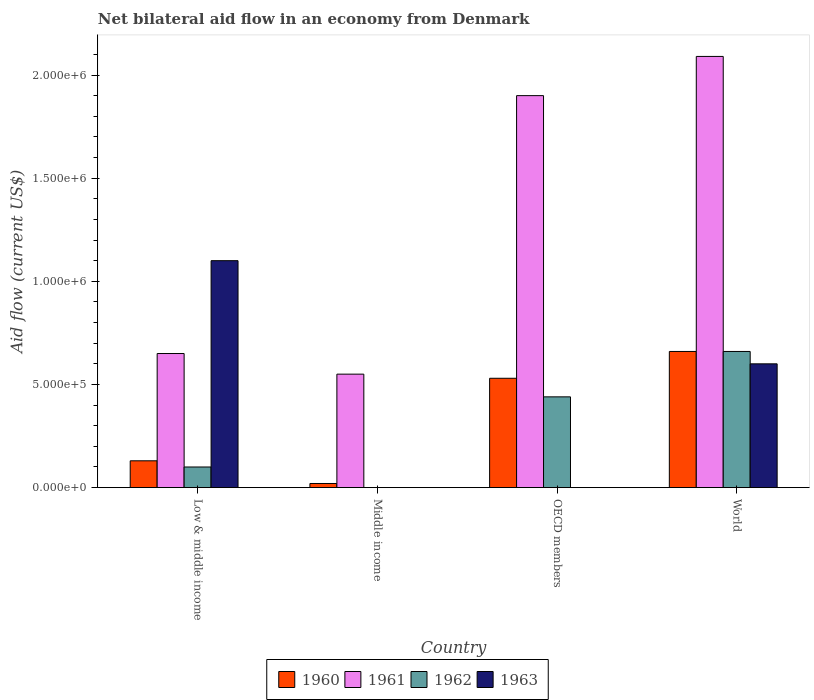How many different coloured bars are there?
Give a very brief answer. 4. Are the number of bars per tick equal to the number of legend labels?
Your response must be concise. No. In how many cases, is the number of bars for a given country not equal to the number of legend labels?
Offer a terse response. 2. What is the total net bilateral aid flow in 1962 in the graph?
Provide a succinct answer. 1.20e+06. What is the difference between the net bilateral aid flow in 1962 in Low & middle income and that in OECD members?
Make the answer very short. -3.40e+05. What is the difference between the net bilateral aid flow in 1961 in OECD members and the net bilateral aid flow in 1960 in Low & middle income?
Your answer should be very brief. 1.77e+06. What is the average net bilateral aid flow in 1961 per country?
Keep it short and to the point. 1.30e+06. What is the difference between the net bilateral aid flow of/in 1961 and net bilateral aid flow of/in 1962 in Low & middle income?
Provide a short and direct response. 5.50e+05. What is the ratio of the net bilateral aid flow in 1962 in OECD members to that in World?
Make the answer very short. 0.67. What is the difference between the highest and the second highest net bilateral aid flow in 1961?
Give a very brief answer. 1.44e+06. What is the difference between the highest and the lowest net bilateral aid flow in 1963?
Give a very brief answer. 1.10e+06. In how many countries, is the net bilateral aid flow in 1960 greater than the average net bilateral aid flow in 1960 taken over all countries?
Make the answer very short. 2. How many legend labels are there?
Your answer should be very brief. 4. How are the legend labels stacked?
Make the answer very short. Horizontal. What is the title of the graph?
Your response must be concise. Net bilateral aid flow in an economy from Denmark. What is the label or title of the X-axis?
Give a very brief answer. Country. What is the Aid flow (current US$) in 1961 in Low & middle income?
Keep it short and to the point. 6.50e+05. What is the Aid flow (current US$) of 1963 in Low & middle income?
Offer a very short reply. 1.10e+06. What is the Aid flow (current US$) in 1961 in Middle income?
Offer a terse response. 5.50e+05. What is the Aid flow (current US$) of 1963 in Middle income?
Keep it short and to the point. 0. What is the Aid flow (current US$) of 1960 in OECD members?
Keep it short and to the point. 5.30e+05. What is the Aid flow (current US$) of 1961 in OECD members?
Offer a very short reply. 1.90e+06. What is the Aid flow (current US$) in 1962 in OECD members?
Give a very brief answer. 4.40e+05. What is the Aid flow (current US$) in 1963 in OECD members?
Give a very brief answer. 0. What is the Aid flow (current US$) in 1961 in World?
Your answer should be compact. 2.09e+06. Across all countries, what is the maximum Aid flow (current US$) of 1960?
Your answer should be very brief. 6.60e+05. Across all countries, what is the maximum Aid flow (current US$) of 1961?
Give a very brief answer. 2.09e+06. Across all countries, what is the maximum Aid flow (current US$) in 1963?
Provide a short and direct response. 1.10e+06. Across all countries, what is the minimum Aid flow (current US$) in 1961?
Offer a terse response. 5.50e+05. Across all countries, what is the minimum Aid flow (current US$) of 1962?
Give a very brief answer. 0. What is the total Aid flow (current US$) in 1960 in the graph?
Your answer should be very brief. 1.34e+06. What is the total Aid flow (current US$) in 1961 in the graph?
Your answer should be very brief. 5.19e+06. What is the total Aid flow (current US$) in 1962 in the graph?
Offer a very short reply. 1.20e+06. What is the total Aid flow (current US$) in 1963 in the graph?
Provide a succinct answer. 1.70e+06. What is the difference between the Aid flow (current US$) in 1960 in Low & middle income and that in OECD members?
Provide a short and direct response. -4.00e+05. What is the difference between the Aid flow (current US$) in 1961 in Low & middle income and that in OECD members?
Offer a very short reply. -1.25e+06. What is the difference between the Aid flow (current US$) of 1960 in Low & middle income and that in World?
Make the answer very short. -5.30e+05. What is the difference between the Aid flow (current US$) in 1961 in Low & middle income and that in World?
Keep it short and to the point. -1.44e+06. What is the difference between the Aid flow (current US$) in 1962 in Low & middle income and that in World?
Offer a very short reply. -5.60e+05. What is the difference between the Aid flow (current US$) of 1963 in Low & middle income and that in World?
Make the answer very short. 5.00e+05. What is the difference between the Aid flow (current US$) in 1960 in Middle income and that in OECD members?
Offer a very short reply. -5.10e+05. What is the difference between the Aid flow (current US$) in 1961 in Middle income and that in OECD members?
Your answer should be compact. -1.35e+06. What is the difference between the Aid flow (current US$) in 1960 in Middle income and that in World?
Offer a very short reply. -6.40e+05. What is the difference between the Aid flow (current US$) of 1961 in Middle income and that in World?
Your response must be concise. -1.54e+06. What is the difference between the Aid flow (current US$) of 1960 in Low & middle income and the Aid flow (current US$) of 1961 in Middle income?
Offer a very short reply. -4.20e+05. What is the difference between the Aid flow (current US$) of 1960 in Low & middle income and the Aid flow (current US$) of 1961 in OECD members?
Keep it short and to the point. -1.77e+06. What is the difference between the Aid flow (current US$) in 1960 in Low & middle income and the Aid flow (current US$) in 1962 in OECD members?
Give a very brief answer. -3.10e+05. What is the difference between the Aid flow (current US$) in 1960 in Low & middle income and the Aid flow (current US$) in 1961 in World?
Make the answer very short. -1.96e+06. What is the difference between the Aid flow (current US$) of 1960 in Low & middle income and the Aid flow (current US$) of 1962 in World?
Your answer should be very brief. -5.30e+05. What is the difference between the Aid flow (current US$) of 1960 in Low & middle income and the Aid flow (current US$) of 1963 in World?
Give a very brief answer. -4.70e+05. What is the difference between the Aid flow (current US$) in 1961 in Low & middle income and the Aid flow (current US$) in 1962 in World?
Your answer should be compact. -10000. What is the difference between the Aid flow (current US$) of 1962 in Low & middle income and the Aid flow (current US$) of 1963 in World?
Make the answer very short. -5.00e+05. What is the difference between the Aid flow (current US$) in 1960 in Middle income and the Aid flow (current US$) in 1961 in OECD members?
Offer a terse response. -1.88e+06. What is the difference between the Aid flow (current US$) of 1960 in Middle income and the Aid flow (current US$) of 1962 in OECD members?
Your response must be concise. -4.20e+05. What is the difference between the Aid flow (current US$) of 1961 in Middle income and the Aid flow (current US$) of 1962 in OECD members?
Provide a short and direct response. 1.10e+05. What is the difference between the Aid flow (current US$) of 1960 in Middle income and the Aid flow (current US$) of 1961 in World?
Ensure brevity in your answer.  -2.07e+06. What is the difference between the Aid flow (current US$) in 1960 in Middle income and the Aid flow (current US$) in 1962 in World?
Offer a terse response. -6.40e+05. What is the difference between the Aid flow (current US$) in 1960 in Middle income and the Aid flow (current US$) in 1963 in World?
Provide a short and direct response. -5.80e+05. What is the difference between the Aid flow (current US$) in 1961 in Middle income and the Aid flow (current US$) in 1962 in World?
Offer a very short reply. -1.10e+05. What is the difference between the Aid flow (current US$) in 1961 in Middle income and the Aid flow (current US$) in 1963 in World?
Make the answer very short. -5.00e+04. What is the difference between the Aid flow (current US$) in 1960 in OECD members and the Aid flow (current US$) in 1961 in World?
Your answer should be very brief. -1.56e+06. What is the difference between the Aid flow (current US$) of 1960 in OECD members and the Aid flow (current US$) of 1963 in World?
Offer a terse response. -7.00e+04. What is the difference between the Aid flow (current US$) in 1961 in OECD members and the Aid flow (current US$) in 1962 in World?
Your answer should be very brief. 1.24e+06. What is the difference between the Aid flow (current US$) in 1961 in OECD members and the Aid flow (current US$) in 1963 in World?
Provide a short and direct response. 1.30e+06. What is the average Aid flow (current US$) in 1960 per country?
Provide a succinct answer. 3.35e+05. What is the average Aid flow (current US$) in 1961 per country?
Provide a short and direct response. 1.30e+06. What is the average Aid flow (current US$) in 1963 per country?
Offer a terse response. 4.25e+05. What is the difference between the Aid flow (current US$) of 1960 and Aid flow (current US$) of 1961 in Low & middle income?
Offer a terse response. -5.20e+05. What is the difference between the Aid flow (current US$) of 1960 and Aid flow (current US$) of 1962 in Low & middle income?
Make the answer very short. 3.00e+04. What is the difference between the Aid flow (current US$) of 1960 and Aid flow (current US$) of 1963 in Low & middle income?
Offer a very short reply. -9.70e+05. What is the difference between the Aid flow (current US$) of 1961 and Aid flow (current US$) of 1963 in Low & middle income?
Keep it short and to the point. -4.50e+05. What is the difference between the Aid flow (current US$) of 1960 and Aid flow (current US$) of 1961 in Middle income?
Offer a terse response. -5.30e+05. What is the difference between the Aid flow (current US$) of 1960 and Aid flow (current US$) of 1961 in OECD members?
Give a very brief answer. -1.37e+06. What is the difference between the Aid flow (current US$) of 1960 and Aid flow (current US$) of 1962 in OECD members?
Provide a succinct answer. 9.00e+04. What is the difference between the Aid flow (current US$) of 1961 and Aid flow (current US$) of 1962 in OECD members?
Your answer should be compact. 1.46e+06. What is the difference between the Aid flow (current US$) of 1960 and Aid flow (current US$) of 1961 in World?
Make the answer very short. -1.43e+06. What is the difference between the Aid flow (current US$) of 1960 and Aid flow (current US$) of 1962 in World?
Provide a short and direct response. 0. What is the difference between the Aid flow (current US$) in 1960 and Aid flow (current US$) in 1963 in World?
Offer a terse response. 6.00e+04. What is the difference between the Aid flow (current US$) in 1961 and Aid flow (current US$) in 1962 in World?
Your answer should be very brief. 1.43e+06. What is the difference between the Aid flow (current US$) in 1961 and Aid flow (current US$) in 1963 in World?
Offer a terse response. 1.49e+06. What is the difference between the Aid flow (current US$) in 1962 and Aid flow (current US$) in 1963 in World?
Keep it short and to the point. 6.00e+04. What is the ratio of the Aid flow (current US$) of 1960 in Low & middle income to that in Middle income?
Your answer should be compact. 6.5. What is the ratio of the Aid flow (current US$) in 1961 in Low & middle income to that in Middle income?
Provide a short and direct response. 1.18. What is the ratio of the Aid flow (current US$) of 1960 in Low & middle income to that in OECD members?
Your response must be concise. 0.25. What is the ratio of the Aid flow (current US$) in 1961 in Low & middle income to that in OECD members?
Provide a short and direct response. 0.34. What is the ratio of the Aid flow (current US$) in 1962 in Low & middle income to that in OECD members?
Give a very brief answer. 0.23. What is the ratio of the Aid flow (current US$) in 1960 in Low & middle income to that in World?
Your response must be concise. 0.2. What is the ratio of the Aid flow (current US$) in 1961 in Low & middle income to that in World?
Keep it short and to the point. 0.31. What is the ratio of the Aid flow (current US$) of 1962 in Low & middle income to that in World?
Give a very brief answer. 0.15. What is the ratio of the Aid flow (current US$) of 1963 in Low & middle income to that in World?
Provide a short and direct response. 1.83. What is the ratio of the Aid flow (current US$) in 1960 in Middle income to that in OECD members?
Give a very brief answer. 0.04. What is the ratio of the Aid flow (current US$) in 1961 in Middle income to that in OECD members?
Your answer should be very brief. 0.29. What is the ratio of the Aid flow (current US$) in 1960 in Middle income to that in World?
Your answer should be compact. 0.03. What is the ratio of the Aid flow (current US$) of 1961 in Middle income to that in World?
Offer a very short reply. 0.26. What is the ratio of the Aid flow (current US$) of 1960 in OECD members to that in World?
Make the answer very short. 0.8. What is the ratio of the Aid flow (current US$) of 1961 in OECD members to that in World?
Your answer should be compact. 0.91. What is the difference between the highest and the second highest Aid flow (current US$) of 1960?
Keep it short and to the point. 1.30e+05. What is the difference between the highest and the second highest Aid flow (current US$) in 1962?
Offer a terse response. 2.20e+05. What is the difference between the highest and the lowest Aid flow (current US$) in 1960?
Offer a terse response. 6.40e+05. What is the difference between the highest and the lowest Aid flow (current US$) of 1961?
Keep it short and to the point. 1.54e+06. What is the difference between the highest and the lowest Aid flow (current US$) in 1962?
Your response must be concise. 6.60e+05. What is the difference between the highest and the lowest Aid flow (current US$) in 1963?
Make the answer very short. 1.10e+06. 